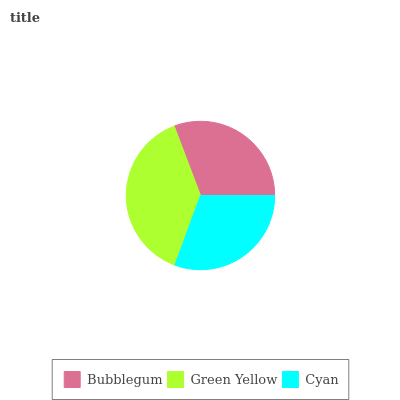Is Cyan the minimum?
Answer yes or no. Yes. Is Green Yellow the maximum?
Answer yes or no. Yes. Is Green Yellow the minimum?
Answer yes or no. No. Is Cyan the maximum?
Answer yes or no. No. Is Green Yellow greater than Cyan?
Answer yes or no. Yes. Is Cyan less than Green Yellow?
Answer yes or no. Yes. Is Cyan greater than Green Yellow?
Answer yes or no. No. Is Green Yellow less than Cyan?
Answer yes or no. No. Is Bubblegum the high median?
Answer yes or no. Yes. Is Bubblegum the low median?
Answer yes or no. Yes. Is Cyan the high median?
Answer yes or no. No. Is Green Yellow the low median?
Answer yes or no. No. 